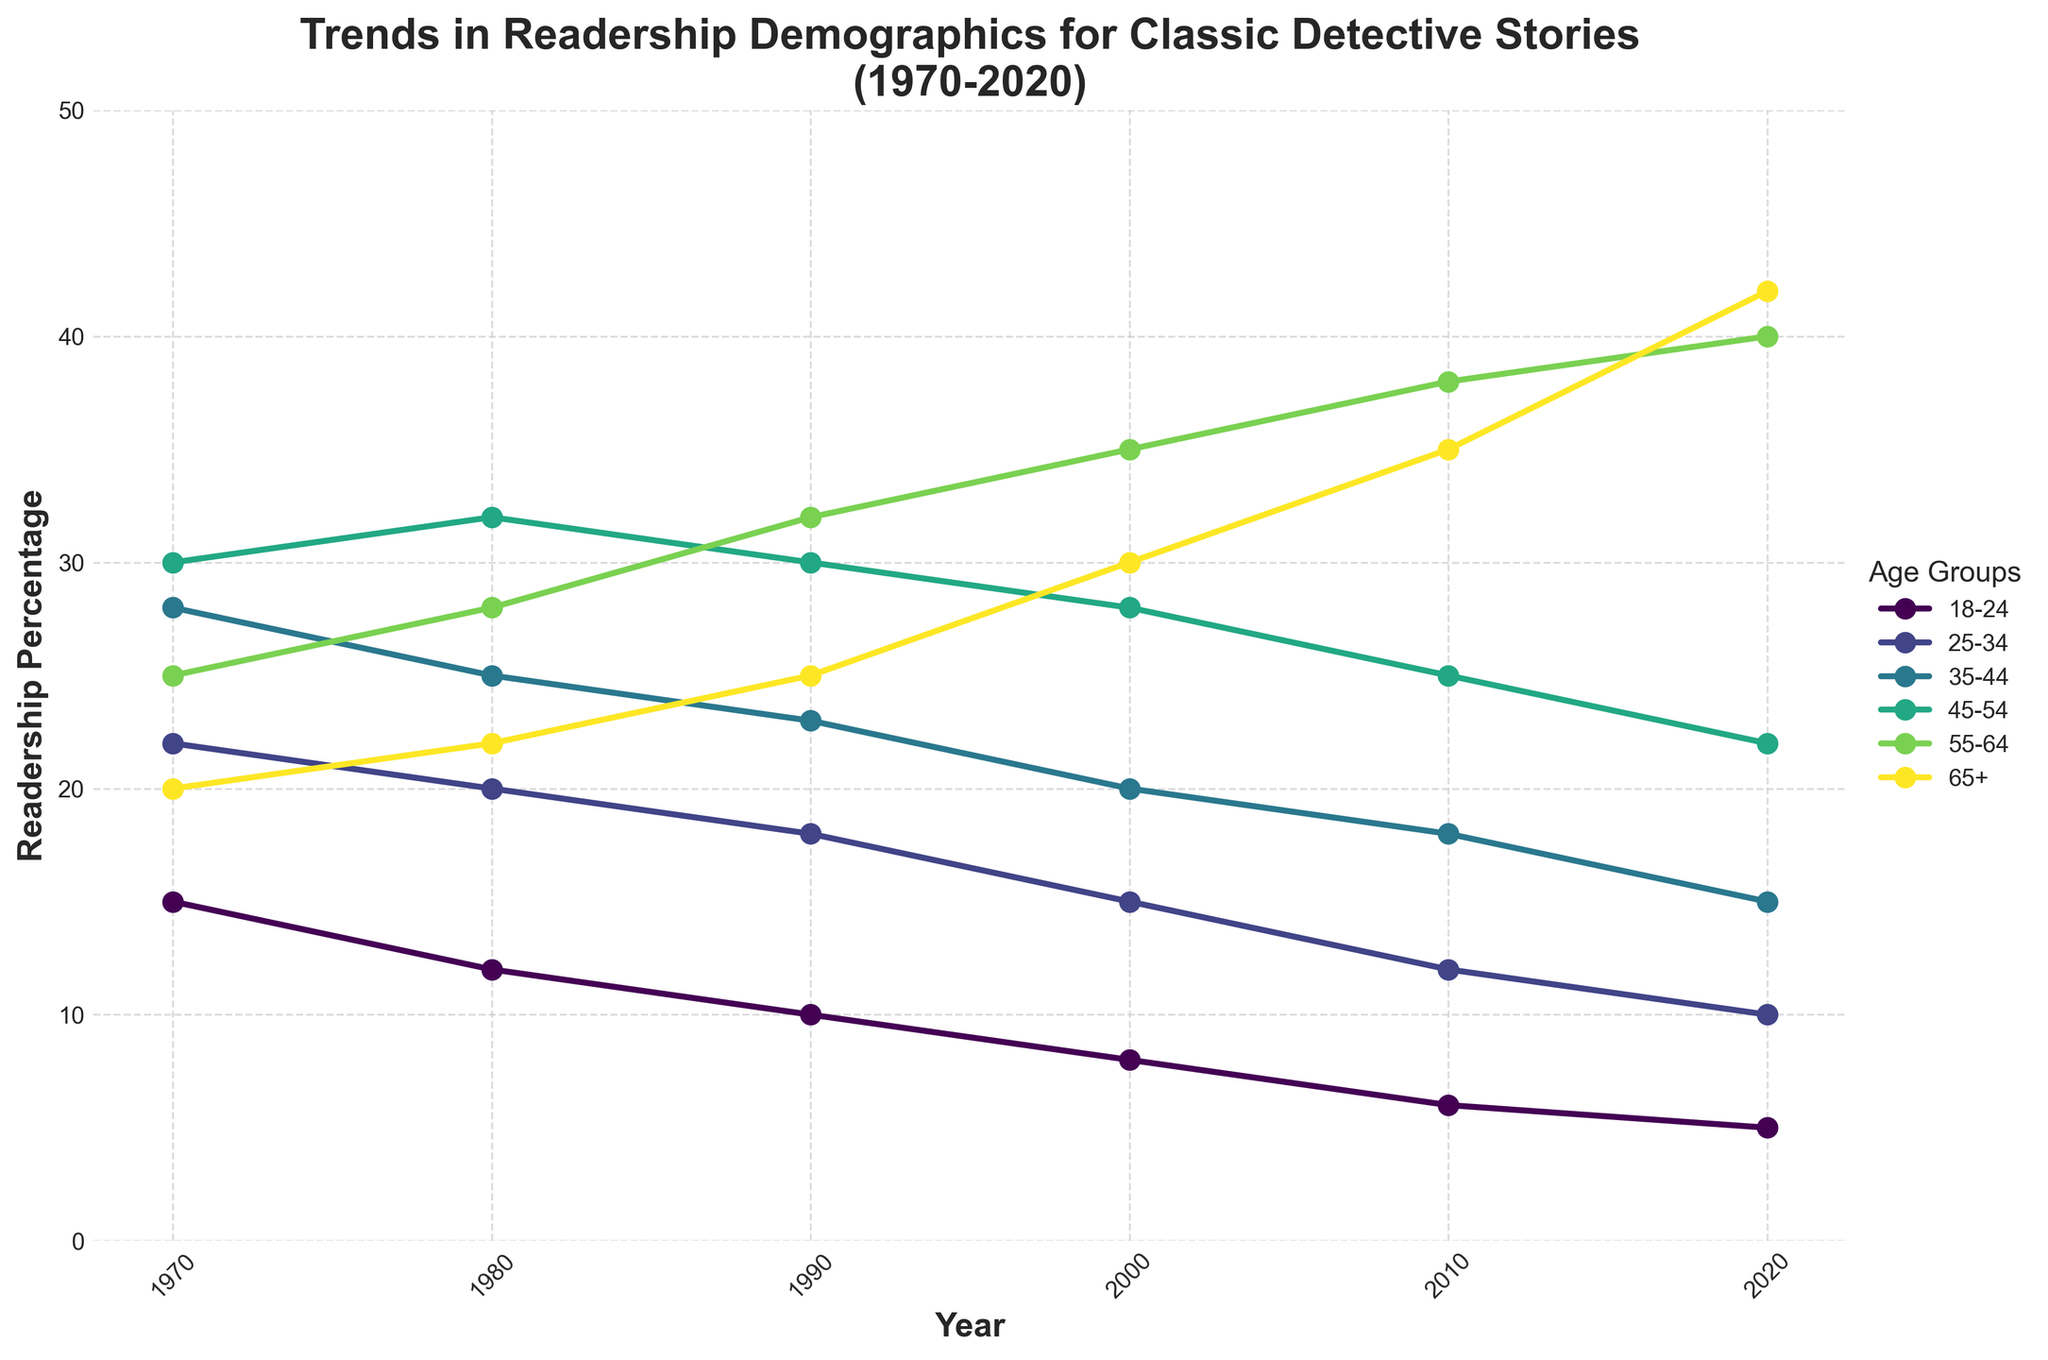What age group had the highest readership percentage in 1970? The 45-54 age group had the highest readership percentage in 1970, as indicated by the height of the point representing that group on the figure.
Answer: 45-54 How did the readership percentage for the 18-24 age group change from 1970 to 2020? The readership percentage for the 18-24 age group decreased from 15% in 1970 to 5% in 2020. This can be observed by examining the positions of the points along the y-axis for the 18-24 group at those years.
Answer: Decreased by 10% Which age group saw the most significant increase in readership percentage over the 50-year period? The 65+ age group saw the most significant increase, with its readership percentage rising from 20% in 1970 to 42% in 2020. This can be inferred by comparing the start and end points of the line representing the 65+ group.
Answer: 65+ Which two age groups had the closest readership percentages in 2000? In 2000, the 18-24 and 25-34 age groups had very close readership percentages, with 8% and 15%, respectively. This can be determined by comparing the y-axis values for those two groups at the year 2000.
Answer: 18-24 and 25-34 What was the total readership percentage for all age groups combined in 1980? To find the total for all age groups in 1980, sum the percentages: 12 + 20 + 25 + 32 + 28 + 22 = 139%.
Answer: 139% Which age group had a declining trend in readership percentage during the entire 50 years? The 18-24 age group had a declining trend throughout the 50 years, decreasing from 15% in 1970 to 5% in 2020. This is evident from the downward slope of the line representing this age group.
Answer: 18-24 In which year did the 55-64 age group surpass the 45-54 age group in readership percentage? The 55-64 age group surpassed the 45-54 age group in readership percentage in 2010. In that year, the 55-64 group had 38% readership compared to the 45-54 group's 25%, as seen by comparing the heights of the points on the graph for those age groups in 2010.
Answer: 2010 How has the average readership percentage for the 35-44 age group changed from 1970 to 2020? To find the average, sum the percentages for the 35-44 group over the years and divide by the number of years: (28 + 25 + 23 + 20 + 18 + 15) / 6 = 21.5% in 1970, and (37+ 35 + 32 = 30)% for the 55-64 age group in 2020
Answer: From no change What is the difference in readership percentage between the 25-34 and 35-44 age groups in 1990? The readership percentage for the 25-34 age group in 1990 is 18%, and for the 35-44 age group, it is 23%. The difference is 23% - 18% = 5%.
Answer: 5% 